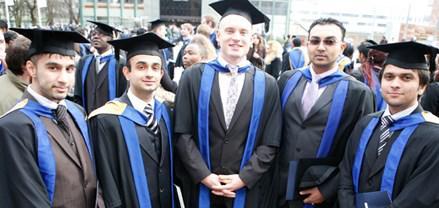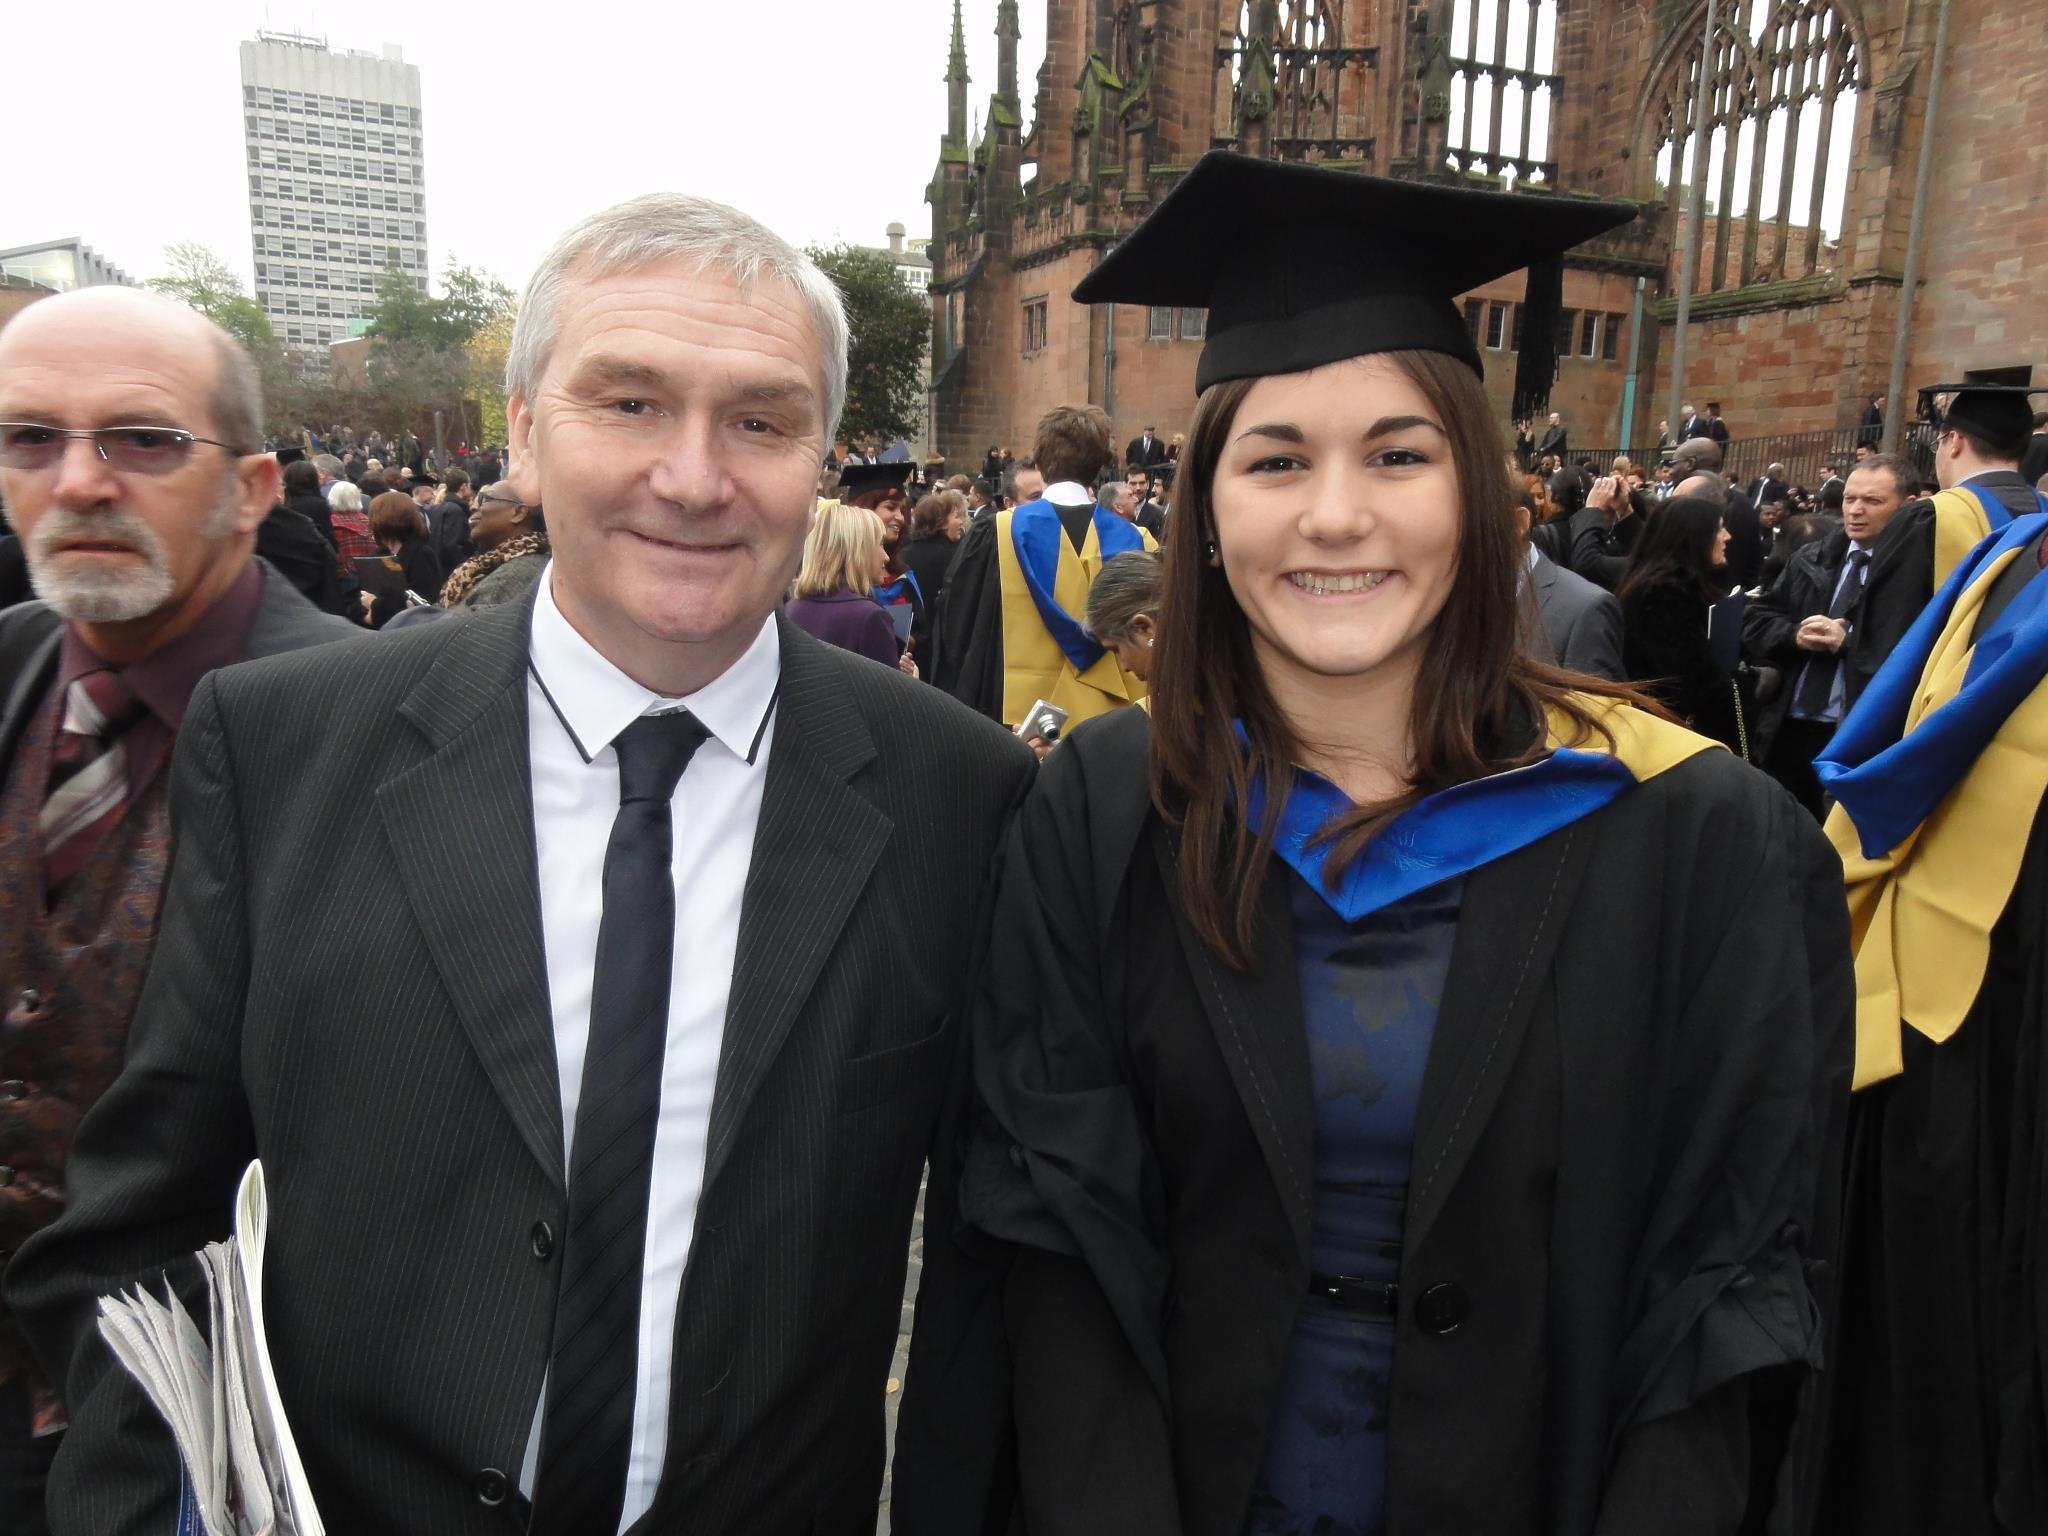The first image is the image on the left, the second image is the image on the right. For the images displayed, is the sentence "An image features a forward-facing female in a black gown and black graduation cap." factually correct? Answer yes or no. Yes. 